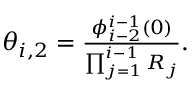Convert formula to latex. <formula><loc_0><loc_0><loc_500><loc_500>\begin{array} { r } { \theta _ { i , 2 } = \frac { \phi _ { i - 2 } ^ { i - 1 } ( 0 ) } { \prod _ { j = 1 } ^ { i - 1 } R _ { j } } . } \end{array}</formula> 